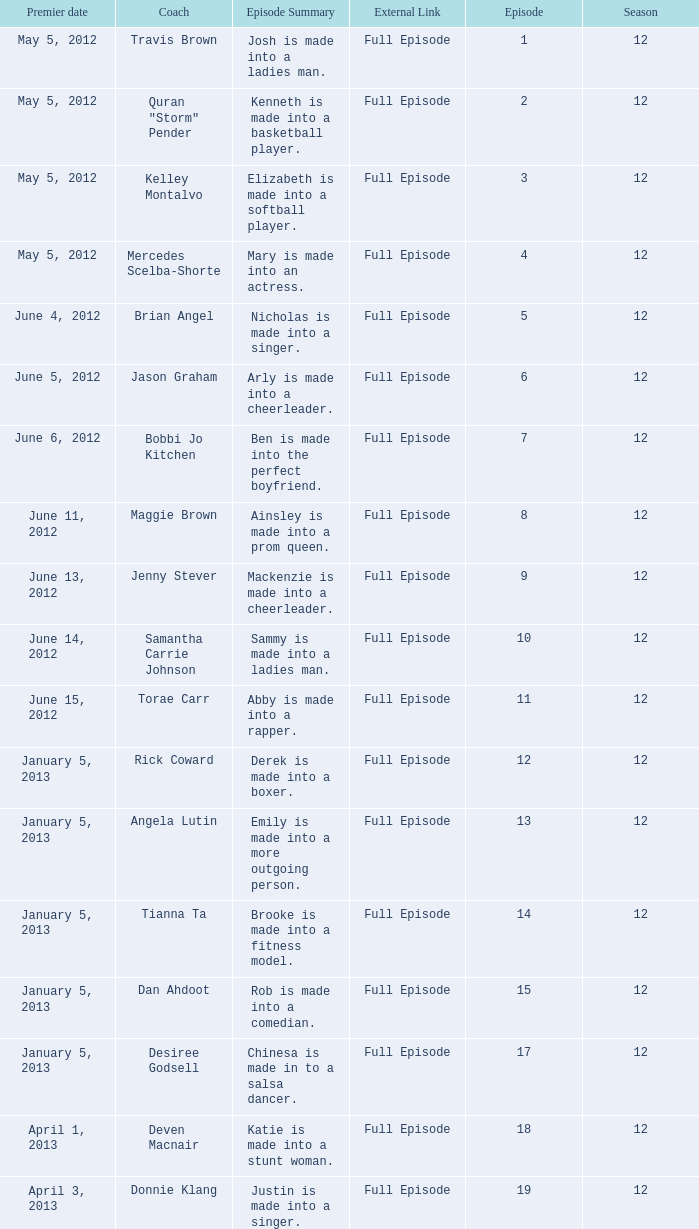Name the episode for travis brown 1.0. Could you help me parse every detail presented in this table? {'header': ['Premier date', 'Coach', 'Episode Summary', 'External Link', 'Episode', 'Season'], 'rows': [['May 5, 2012', 'Travis Brown', 'Josh is made into a ladies man.', 'Full Episode', '1', '12'], ['May 5, 2012', 'Quran "Storm" Pender', 'Kenneth is made into a basketball player.', 'Full Episode', '2', '12'], ['May 5, 2012', 'Kelley Montalvo', 'Elizabeth is made into a softball player.', 'Full Episode', '3', '12'], ['May 5, 2012', 'Mercedes Scelba-Shorte', 'Mary is made into an actress.', 'Full Episode', '4', '12'], ['June 4, 2012', 'Brian Angel', 'Nicholas is made into a singer.', 'Full Episode', '5', '12'], ['June 5, 2012', 'Jason Graham', 'Arly is made into a cheerleader.', 'Full Episode', '6', '12'], ['June 6, 2012', 'Bobbi Jo Kitchen', 'Ben is made into the perfect boyfriend.', 'Full Episode', '7', '12'], ['June 11, 2012', 'Maggie Brown', 'Ainsley is made into a prom queen.', 'Full Episode', '8', '12'], ['June 13, 2012', 'Jenny Stever', 'Mackenzie is made into a cheerleader.', 'Full Episode', '9', '12'], ['June 14, 2012', 'Samantha Carrie Johnson', 'Sammy is made into a ladies man.', 'Full Episode', '10', '12'], ['June 15, 2012', 'Torae Carr', 'Abby is made into a rapper.', 'Full Episode', '11', '12'], ['January 5, 2013', 'Rick Coward', 'Derek is made into a boxer.', 'Full Episode', '12', '12'], ['January 5, 2013', 'Angela Lutin', 'Emily is made into a more outgoing person.', 'Full Episode', '13', '12'], ['January 5, 2013', 'Tianna Ta', 'Brooke is made into a fitness model.', 'Full Episode', '14', '12'], ['January 5, 2013', 'Dan Ahdoot', 'Rob is made into a comedian.', 'Full Episode', '15', '12'], ['January 5, 2013', 'Desiree Godsell', 'Chinesa is made in to a salsa dancer.', 'Full Episode', '17', '12'], ['April 1, 2013', 'Deven Macnair', 'Katie is made into a stunt woman.', 'Full Episode', '18', '12'], ['April 3, 2013', 'Donnie Klang', 'Justin is made into a singer.', 'Full Episode', '19', '12']]} 